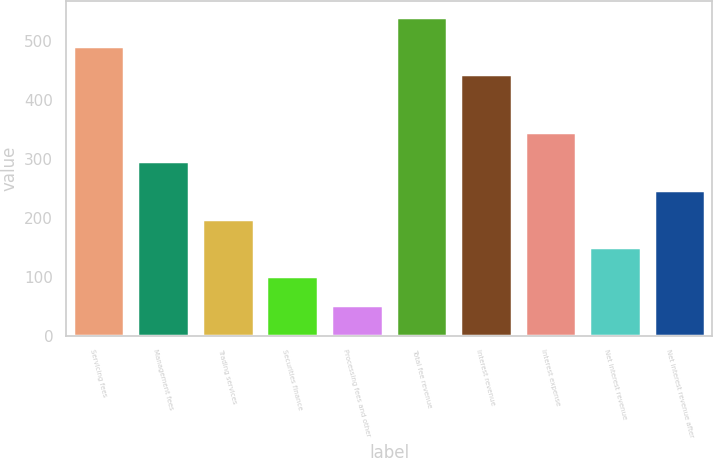Convert chart to OTSL. <chart><loc_0><loc_0><loc_500><loc_500><bar_chart><fcel>Servicing fees<fcel>Management fees<fcel>Trading services<fcel>Securities finance<fcel>Processing fees and other<fcel>Total fee revenue<fcel>Interest revenue<fcel>Interest expense<fcel>Net interest revenue<fcel>Net interest revenue after<nl><fcel>492<fcel>296.4<fcel>198.6<fcel>100.8<fcel>51.9<fcel>540.9<fcel>443.1<fcel>345.3<fcel>149.7<fcel>247.5<nl></chart> 